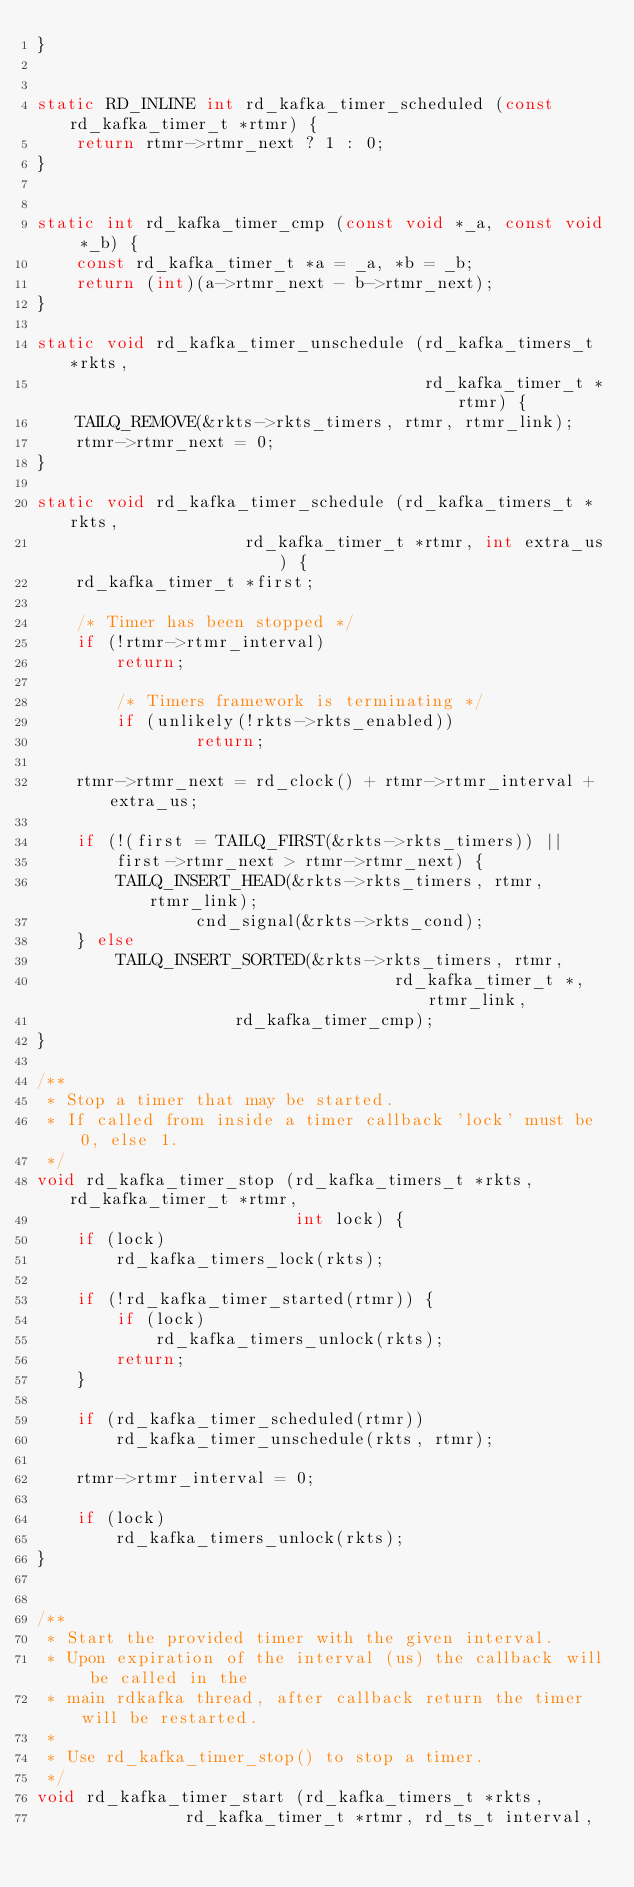<code> <loc_0><loc_0><loc_500><loc_500><_C_>}


static RD_INLINE int rd_kafka_timer_scheduled (const rd_kafka_timer_t *rtmr) {
	return rtmr->rtmr_next ? 1 : 0;
}


static int rd_kafka_timer_cmp (const void *_a, const void *_b) {
	const rd_kafka_timer_t *a = _a, *b = _b;
	return (int)(a->rtmr_next - b->rtmr_next);
}

static void rd_kafka_timer_unschedule (rd_kafka_timers_t *rkts,
                                       rd_kafka_timer_t *rtmr) {
	TAILQ_REMOVE(&rkts->rkts_timers, rtmr, rtmr_link);
	rtmr->rtmr_next = 0;
}

static void rd_kafka_timer_schedule (rd_kafka_timers_t *rkts,
				     rd_kafka_timer_t *rtmr, int extra_us) {
	rd_kafka_timer_t *first;

	/* Timer has been stopped */
	if (!rtmr->rtmr_interval)
		return;

        /* Timers framework is terminating */
        if (unlikely(!rkts->rkts_enabled))
                return;

	rtmr->rtmr_next = rd_clock() + rtmr->rtmr_interval + extra_us;

	if (!(first = TAILQ_FIRST(&rkts->rkts_timers)) ||
	    first->rtmr_next > rtmr->rtmr_next) {
		TAILQ_INSERT_HEAD(&rkts->rkts_timers, rtmr, rtmr_link);
                cnd_signal(&rkts->rkts_cond);
	} else
		TAILQ_INSERT_SORTED(&rkts->rkts_timers, rtmr,
                                    rd_kafka_timer_t *, rtmr_link,
				    rd_kafka_timer_cmp);
}

/**
 * Stop a timer that may be started.
 * If called from inside a timer callback 'lock' must be 0, else 1.
 */
void rd_kafka_timer_stop (rd_kafka_timers_t *rkts, rd_kafka_timer_t *rtmr,
                          int lock) {
	if (lock)
		rd_kafka_timers_lock(rkts);

	if (!rd_kafka_timer_started(rtmr)) {
		if (lock)
			rd_kafka_timers_unlock(rkts);
		return;
	}

	if (rd_kafka_timer_scheduled(rtmr))
		rd_kafka_timer_unschedule(rkts, rtmr);

	rtmr->rtmr_interval = 0;

	if (lock)
		rd_kafka_timers_unlock(rkts);
}


/**
 * Start the provided timer with the given interval.
 * Upon expiration of the interval (us) the callback will be called in the
 * main rdkafka thread, after callback return the timer will be restarted.
 *
 * Use rd_kafka_timer_stop() to stop a timer.
 */
void rd_kafka_timer_start (rd_kafka_timers_t *rkts,
			   rd_kafka_timer_t *rtmr, rd_ts_t interval,</code> 